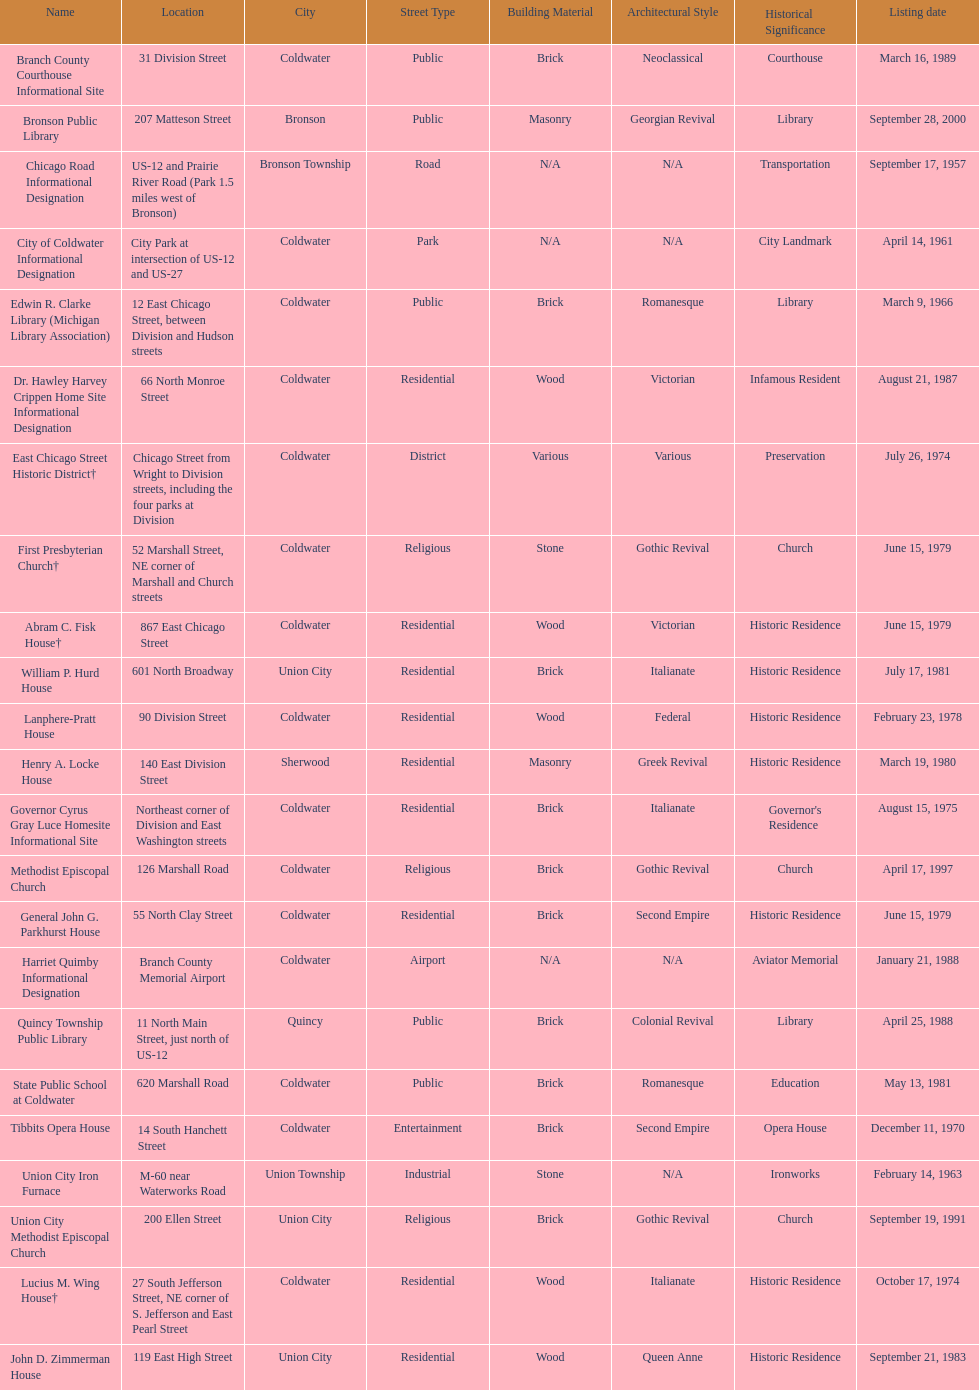Name a site that was listed no later than 1960. Chicago Road Informational Designation. 